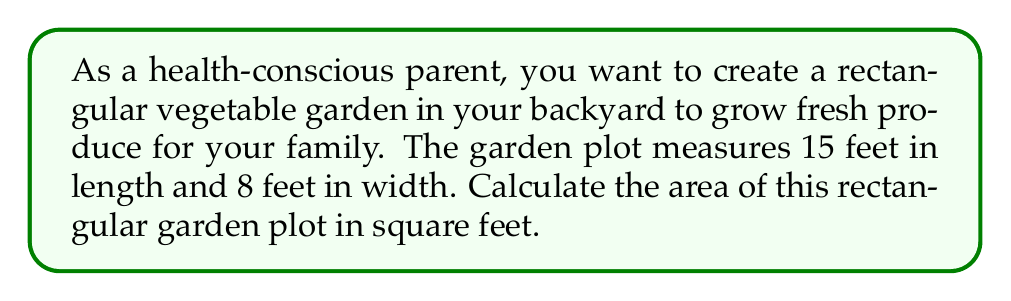Help me with this question. To calculate the area of a rectangular garden plot, we need to multiply its length by its width. Let's follow these steps:

1. Identify the given dimensions:
   Length $(l) = 15$ feet
   Width $(w) = 8$ feet

2. Use the formula for the area of a rectangle:
   $$A = l \times w$$
   Where $A$ is the area, $l$ is the length, and $w$ is the width.

3. Substitute the values into the formula:
   $$A = 15 \text{ feet} \times 8 \text{ feet}$$

4. Perform the multiplication:
   $$A = 120 \text{ square feet}$$

[asy]
unitsize(0.5cm);
draw((0,0)--(15,0)--(15,8)--(0,8)--cycle);
label("15 ft", (7.5,0), S);
label("8 ft", (15,4), E);
label("Area = 120 sq ft", (7.5,4), C);
[/asy]

The area of the rectangular garden plot is 120 square feet.
Answer: $120 \text{ ft}^2$ 